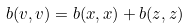<formula> <loc_0><loc_0><loc_500><loc_500>b ( v , v ) = b ( x , x ) + b ( z , z )</formula> 